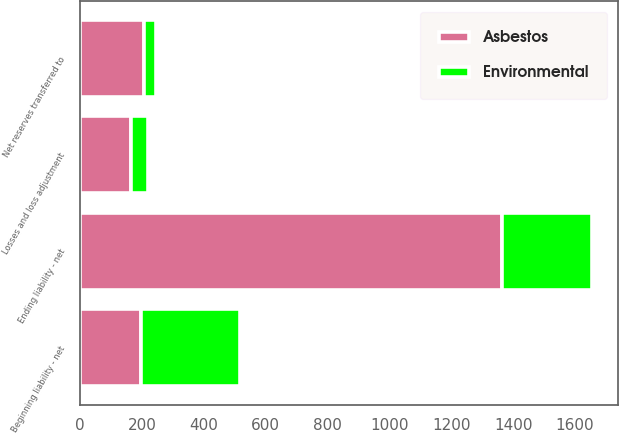Convert chart. <chart><loc_0><loc_0><loc_500><loc_500><stacked_bar_chart><ecel><fcel>Beginning liability - net<fcel>Losses and loss adjustment<fcel>Net reserves transferred to<fcel>Ending liability - net<nl><fcel>Asbestos<fcel>197<fcel>165<fcel>205<fcel>1363<nl><fcel>Environmental<fcel>318<fcel>55<fcel>41<fcel>292<nl></chart> 